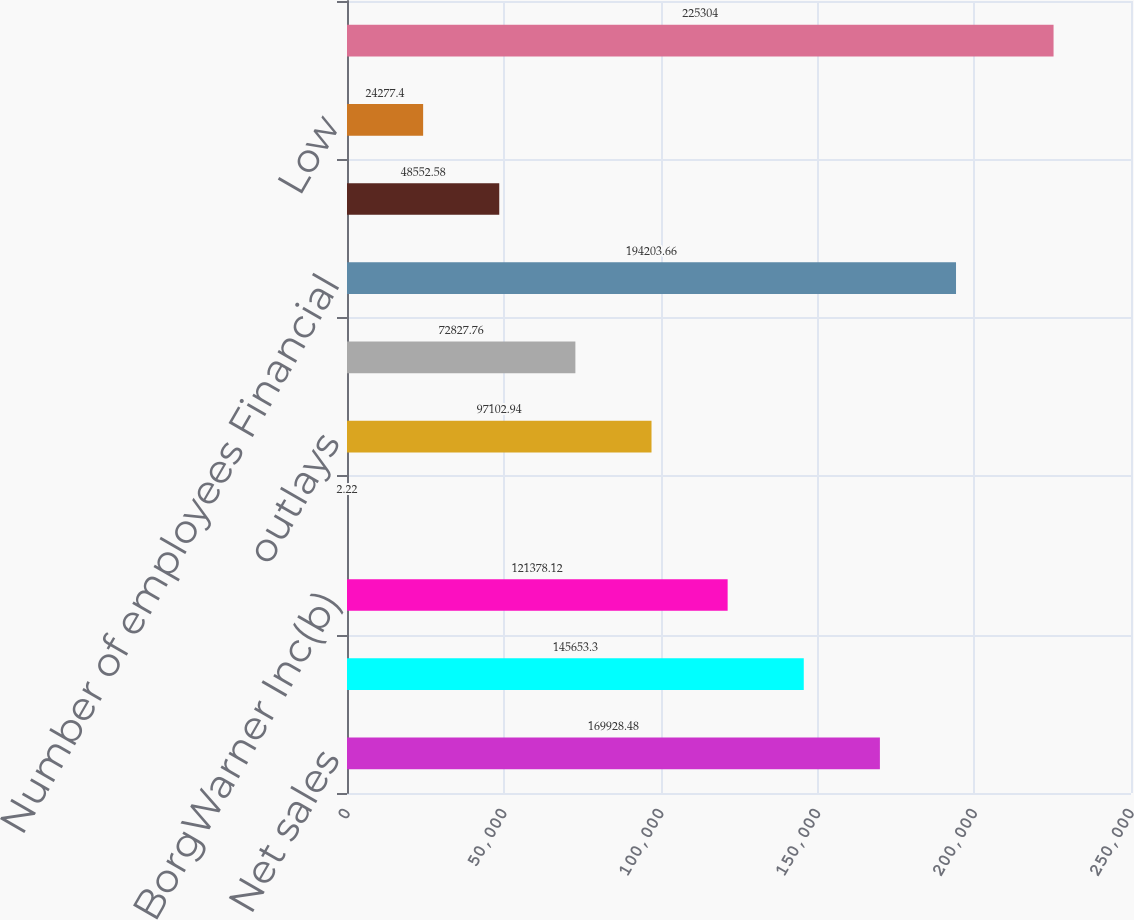Convert chart. <chart><loc_0><loc_0><loc_500><loc_500><bar_chart><fcel>Net sales<fcel>Operating income(b) Net<fcel>BorgWarner Inc(b)<fcel>Earnings per share - basic(c)<fcel>outlays<fcel>Depreciation and tooling<fcel>Number of employees Financial<fcel>High<fcel>Low<fcel>Basic<nl><fcel>169928<fcel>145653<fcel>121378<fcel>2.22<fcel>97102.9<fcel>72827.8<fcel>194204<fcel>48552.6<fcel>24277.4<fcel>225304<nl></chart> 